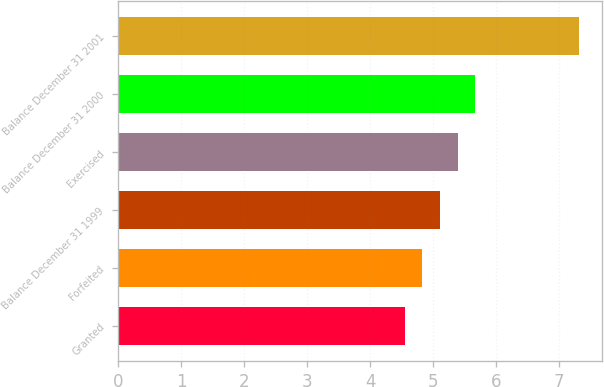<chart> <loc_0><loc_0><loc_500><loc_500><bar_chart><fcel>Granted<fcel>Forfeited<fcel>Balance December 31 1999<fcel>Exercised<fcel>Balance December 31 2000<fcel>Balance December 31 2001<nl><fcel>4.55<fcel>4.83<fcel>5.11<fcel>5.39<fcel>5.67<fcel>7.31<nl></chart> 